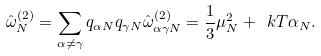Convert formula to latex. <formula><loc_0><loc_0><loc_500><loc_500>\hat { \omega } ^ { ( 2 ) } _ { N } = \sum _ { \alpha \neq \gamma } q _ { \alpha N } q _ { \gamma N } \hat { \omega } _ { \alpha \gamma N } ^ { ( 2 ) } = \frac { 1 } { 3 } \mu _ { N } ^ { 2 } + \ k T \alpha _ { N } .</formula> 